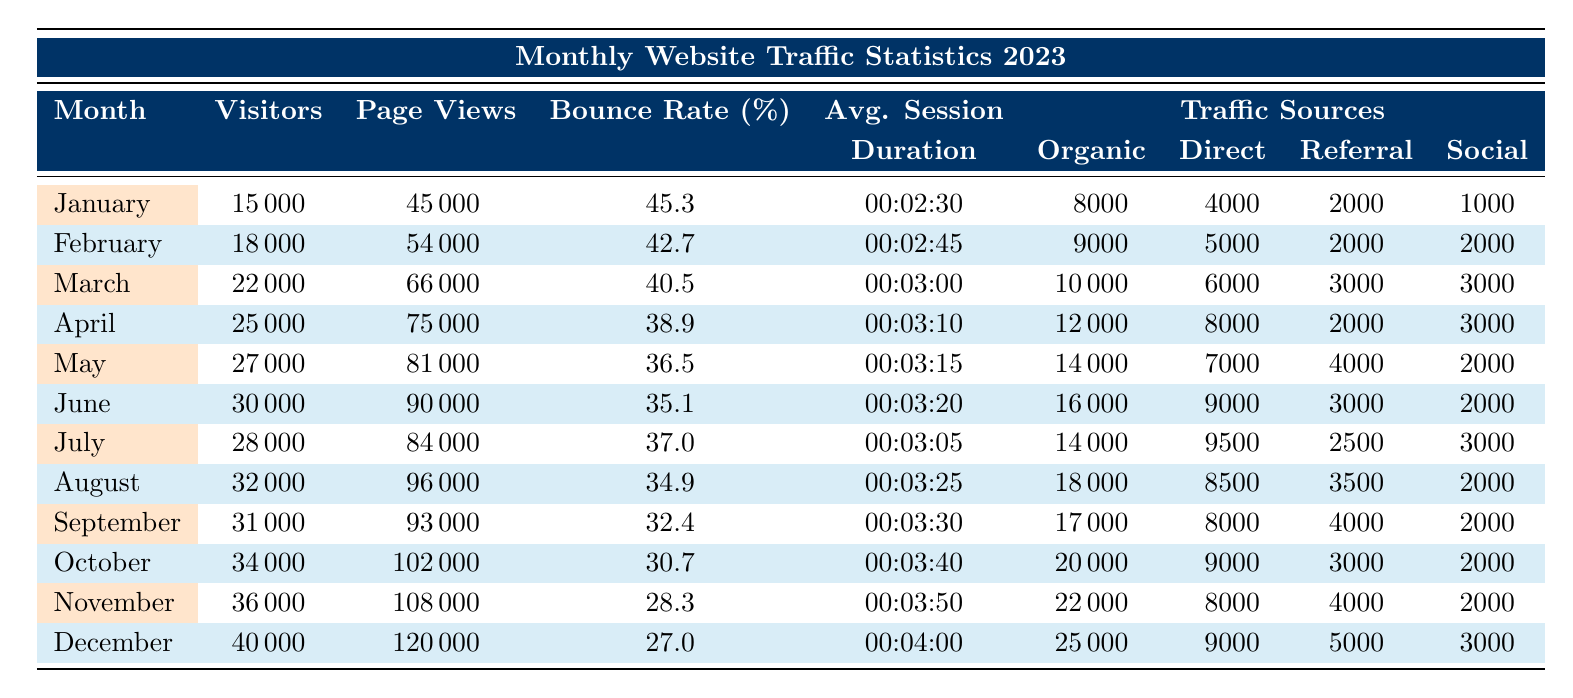What was the highest number of visitors recorded in a month? By reviewing the "Visitors" column, the highest value is found in December with 40,000 visitors.
Answer: 40000 Which month had the lowest bounce rate? Looking at the "Bounce Rate" column, December has the lowest percentage at 27.0%.
Answer: 27.0 What was the average page views for the first half of the year (January to June)? The total page views for the first six months are calculated as follows: 45000 + 54000 + 66000 + 75000 + 81000 + 90000 = 360000. There are 6 months, so the average is 360000 / 6 = 60000.
Answer: 60000 In which month did organic search traffic exceed 20,000 visits? By checking the "Organic" traffic source column, organic search traffic first exceeded 20,000 visits in November, which had 22,000 visits.
Answer: November Did the number of visitors increase every month from January to December? By analyzing the "Visitors" column for each month, the number of visitors consistently increased each month without any decreases.
Answer: Yes What was the average session duration for the month with the highest bounce rate? The month with the highest bounce rate is January with 45.3%. The average session duration for January is 00:02:30. Thus, the average session duration for the month is 00:02:30.
Answer: 00:02:30 How many total visitors were there in March, April, and May combined? The total visitors for these three months are 22000 (March) + 25000 (April) + 27000 (May) = 74000.
Answer: 74000 Did the traffic from social media remain constant in the first half of the year? By examining the "Social" media column for each month from January to June, it is evident that the social media visitors varied: January had 1000, February 2000, March 3000, April 3000, May 2000, June 2000, indicating fluctuations.
Answer: No What was the percentage decrease in bounce rate from January to October? The bounce rate in January is 45.3%, and in October, it's 30.7%. The decrease calculated is (45.3 - 30.7) = 14.6%. Therefore, the percentage decrease is (14.6 / 45.3) * 100 = 32.3%.
Answer: 32.3% 